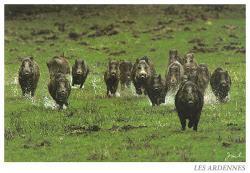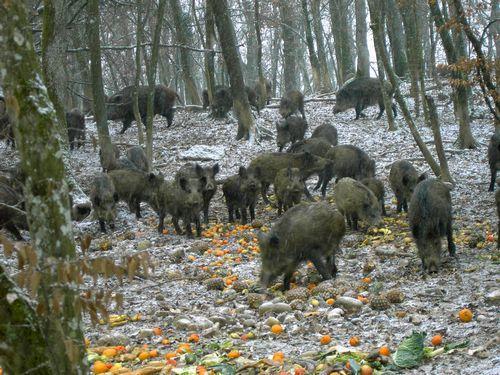The first image is the image on the left, the second image is the image on the right. Examine the images to the left and right. Is the description "One image shows a group of hogs on a bright green field." accurate? Answer yes or no. Yes. The first image is the image on the left, the second image is the image on the right. Considering the images on both sides, is "The animals in one of the images are moving directly toward the camera." valid? Answer yes or no. Yes. 